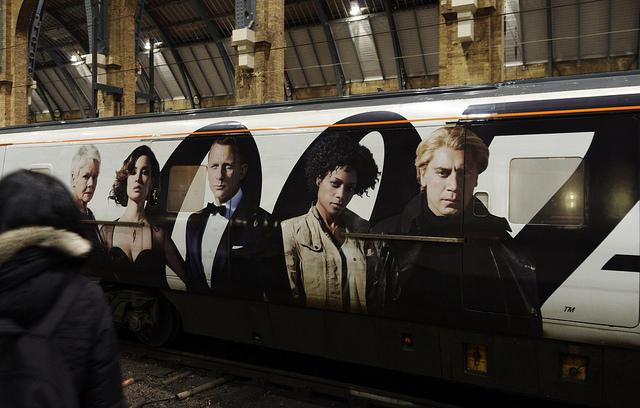What numbers are on the train?
Quick response, please. 007. Who is the man on the left?
Short answer required. Daniel craig. What movie franchise is in the photo?
Give a very brief answer. 007. 